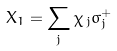Convert formula to latex. <formula><loc_0><loc_0><loc_500><loc_500>X _ { 1 } = \sum _ { j } { \chi } _ { \, { j } } \sigma _ { j } ^ { + }</formula> 